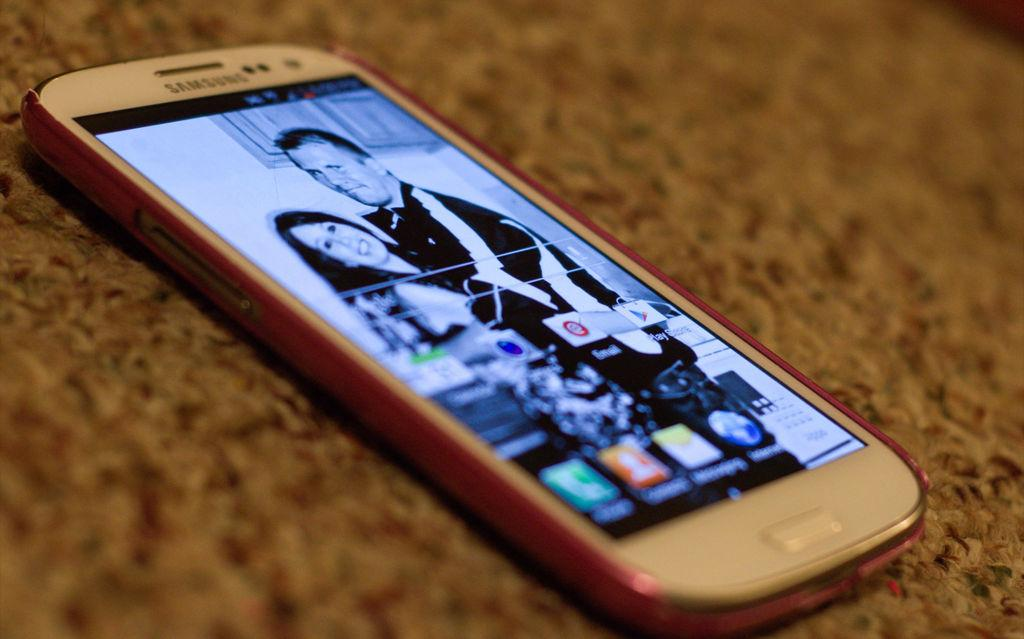<image>
Present a compact description of the photo's key features. A phone on a home screen with the play store app appearing in the first row 